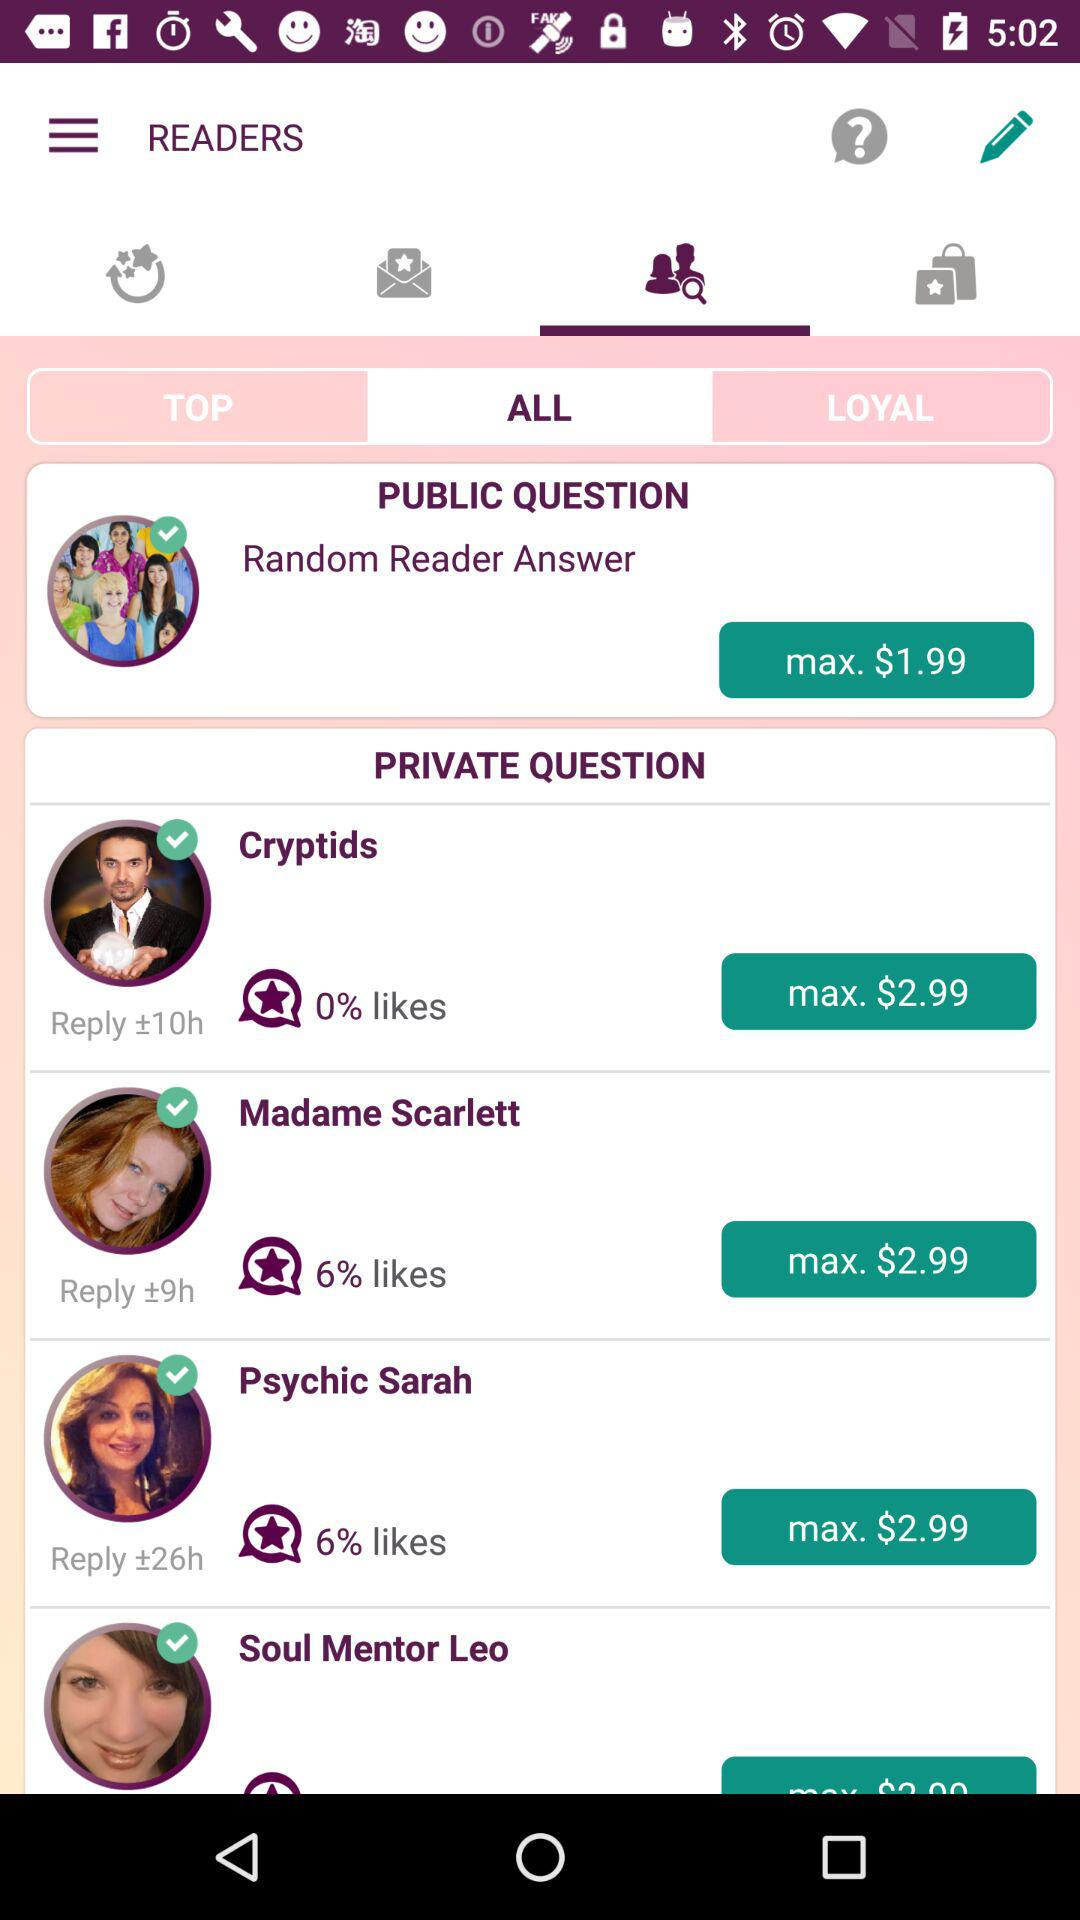How many items have a max price of $2.99?
Answer the question using a single word or phrase. 3 